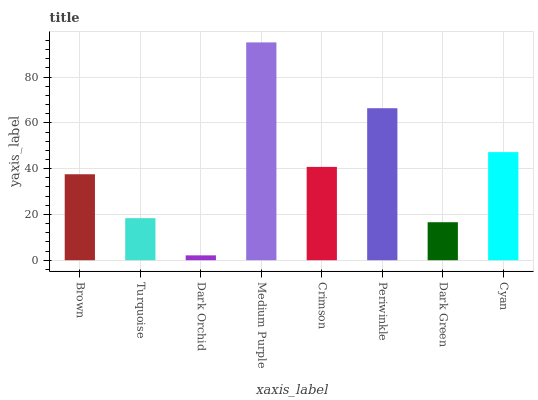Is Dark Orchid the minimum?
Answer yes or no. Yes. Is Medium Purple the maximum?
Answer yes or no. Yes. Is Turquoise the minimum?
Answer yes or no. No. Is Turquoise the maximum?
Answer yes or no. No. Is Brown greater than Turquoise?
Answer yes or no. Yes. Is Turquoise less than Brown?
Answer yes or no. Yes. Is Turquoise greater than Brown?
Answer yes or no. No. Is Brown less than Turquoise?
Answer yes or no. No. Is Crimson the high median?
Answer yes or no. Yes. Is Brown the low median?
Answer yes or no. Yes. Is Turquoise the high median?
Answer yes or no. No. Is Periwinkle the low median?
Answer yes or no. No. 